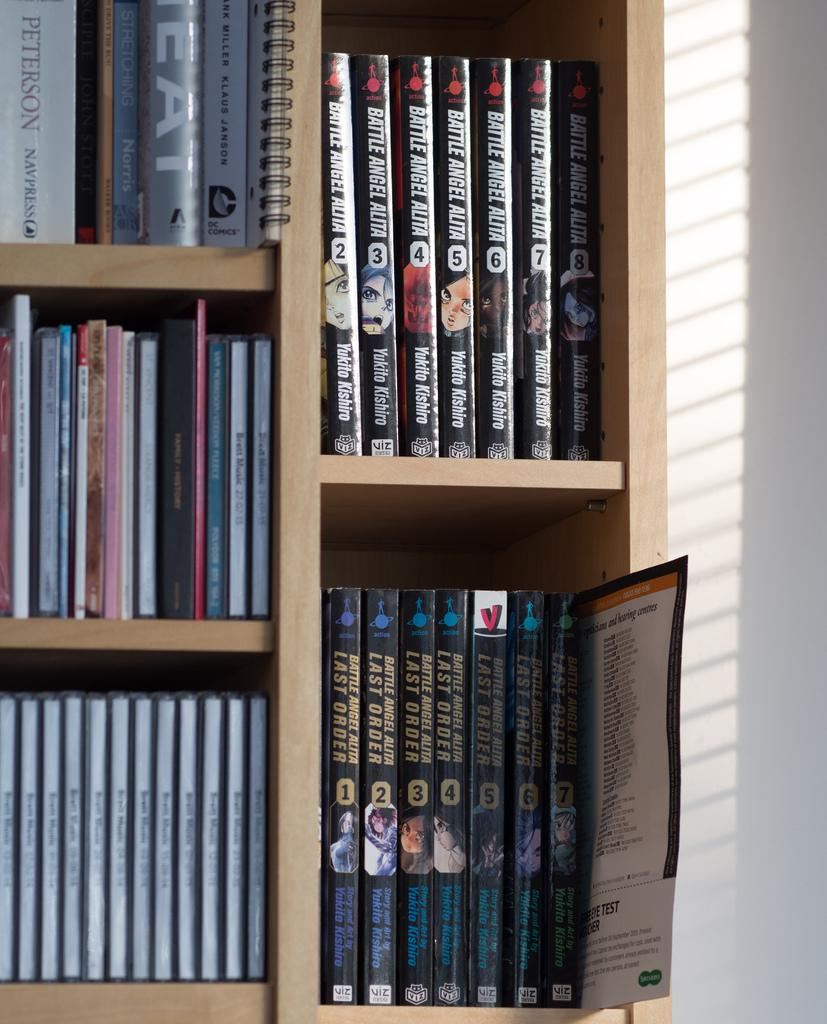<image>
Summarize the visual content of the image. Bookcase with bunch of various books including Last Order. 